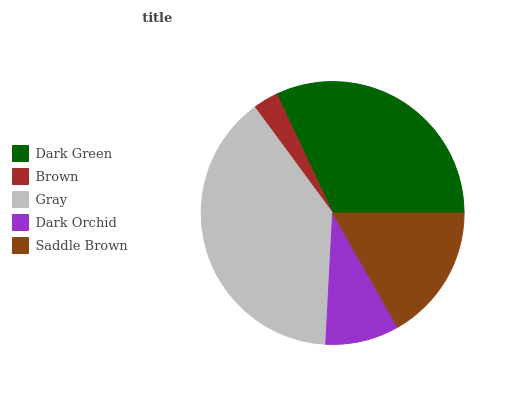Is Brown the minimum?
Answer yes or no. Yes. Is Gray the maximum?
Answer yes or no. Yes. Is Gray the minimum?
Answer yes or no. No. Is Brown the maximum?
Answer yes or no. No. Is Gray greater than Brown?
Answer yes or no. Yes. Is Brown less than Gray?
Answer yes or no. Yes. Is Brown greater than Gray?
Answer yes or no. No. Is Gray less than Brown?
Answer yes or no. No. Is Saddle Brown the high median?
Answer yes or no. Yes. Is Saddle Brown the low median?
Answer yes or no. Yes. Is Gray the high median?
Answer yes or no. No. Is Dark Green the low median?
Answer yes or no. No. 